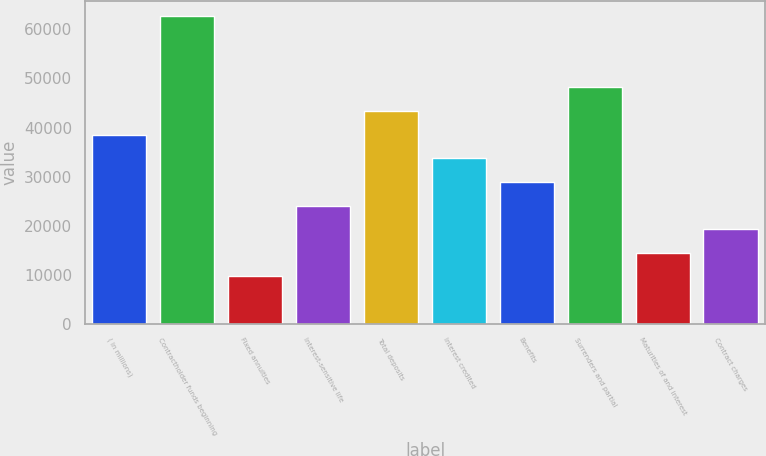<chart> <loc_0><loc_0><loc_500><loc_500><bar_chart><fcel>( in millions)<fcel>Contractholder funds beginning<fcel>Fixed annuities<fcel>Interest-sensitive life<fcel>Total deposits<fcel>Interest credited<fcel>Benefits<fcel>Surrenders and partial<fcel>Maturities of and interest<fcel>Contract charges<nl><fcel>38558.4<fcel>62649.9<fcel>9648.6<fcel>24103.5<fcel>43376.7<fcel>33740.1<fcel>28921.8<fcel>48195<fcel>14466.9<fcel>19285.2<nl></chart> 